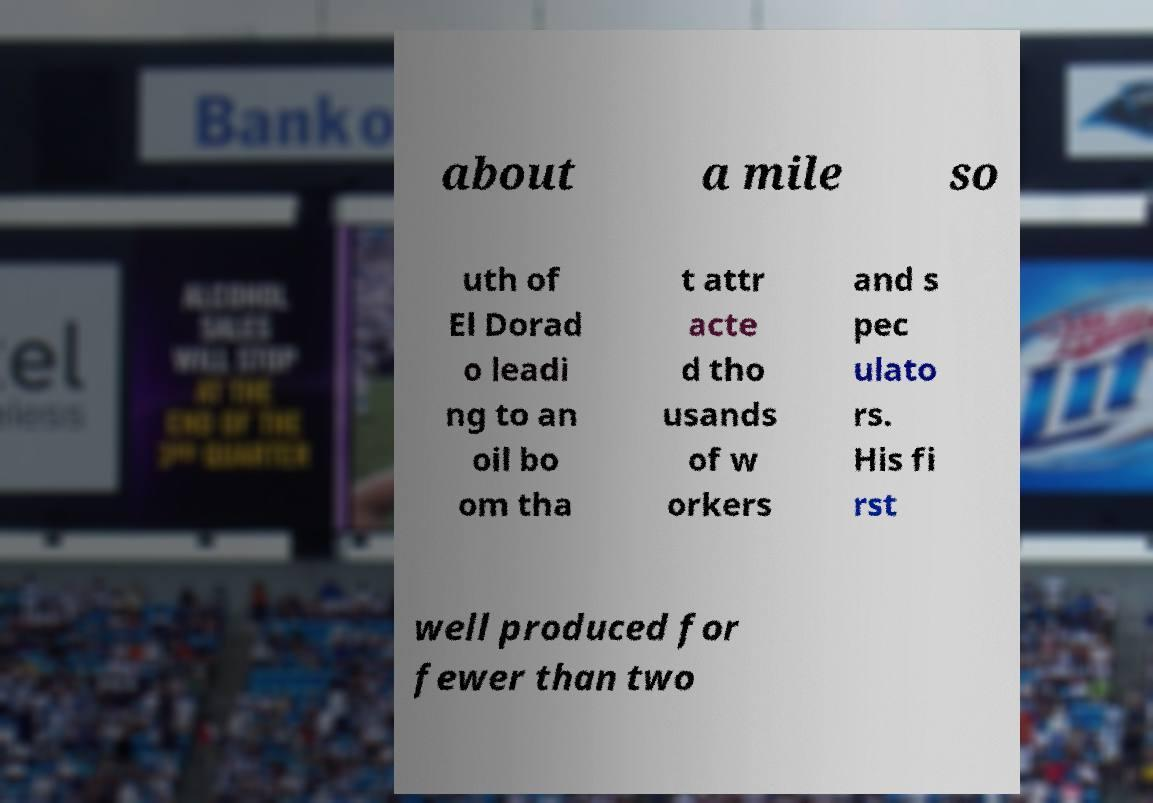Can you accurately transcribe the text from the provided image for me? about a mile so uth of El Dorad o leadi ng to an oil bo om tha t attr acte d tho usands of w orkers and s pec ulato rs. His fi rst well produced for fewer than two 